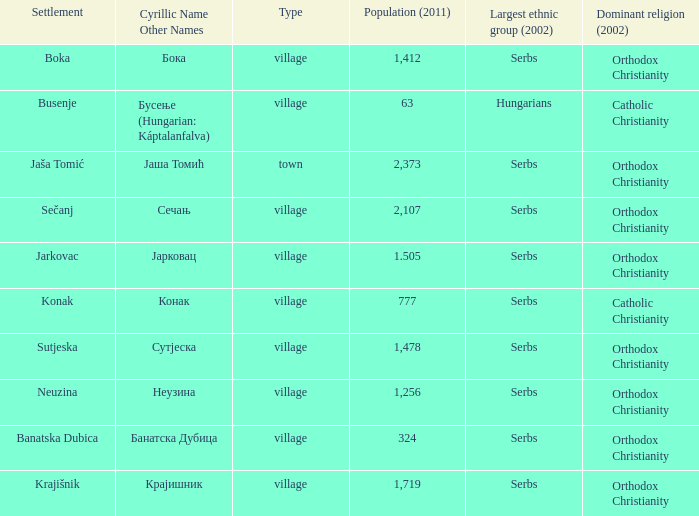What town has the population of 777? Конак. 